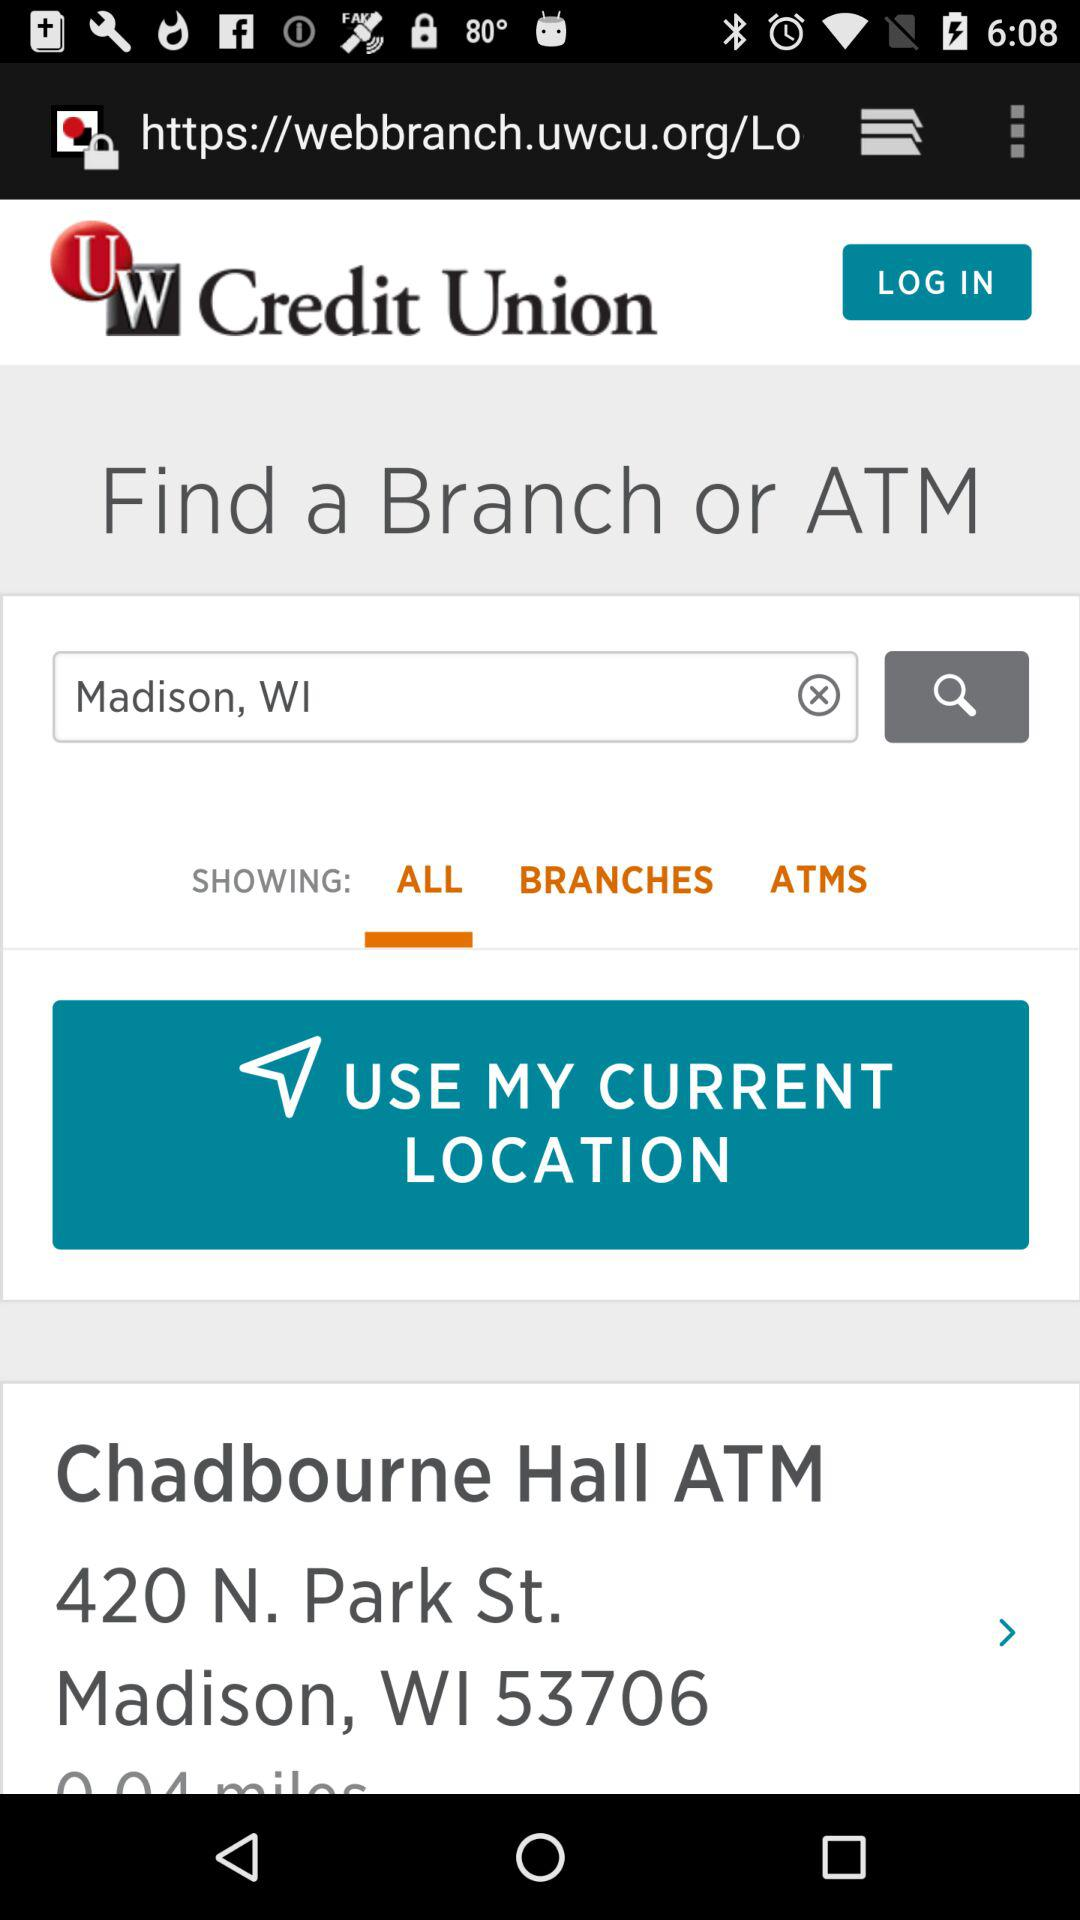Which tab is selected? The tab "ALL" is selected. 